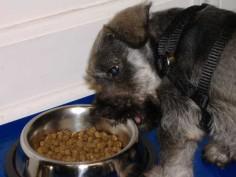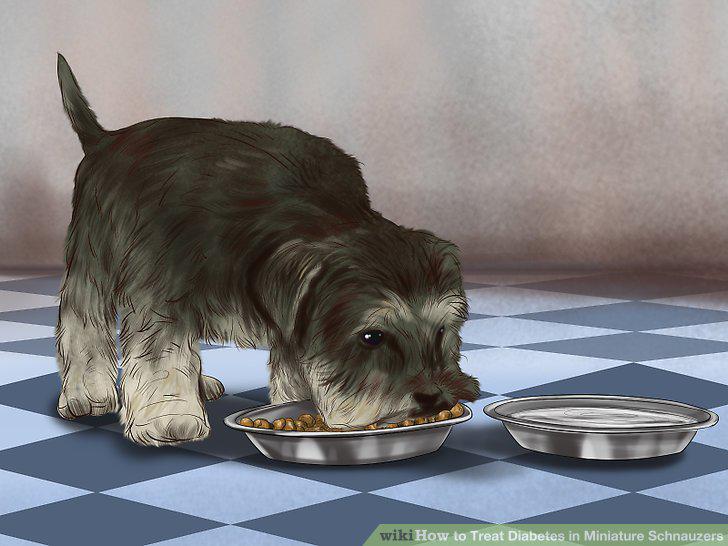The first image is the image on the left, the second image is the image on the right. Considering the images on both sides, is "One dog is eating and the other dog is not near food." valid? Answer yes or no. No. 